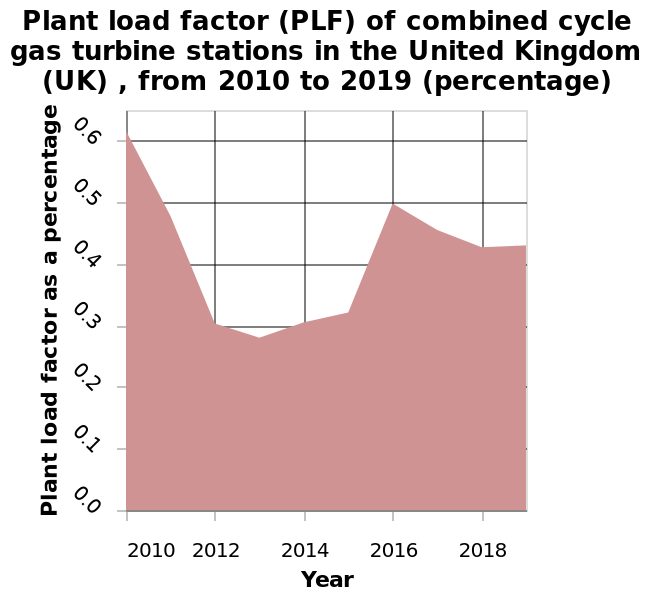<image>
please summary the statistics and relations of the chart Plant load factor of UK of combined cycle has stations there doesn't seem to be a noticeable trend other than its overall decreased. What does PLF stand for in the context of the chart? PLF stands for Plant load factor. 